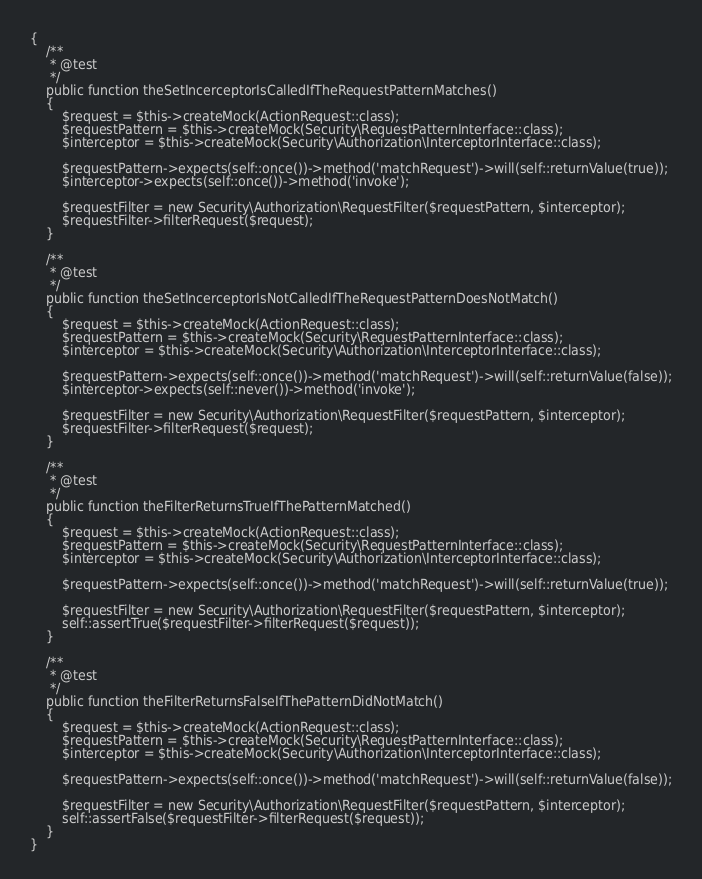<code> <loc_0><loc_0><loc_500><loc_500><_PHP_>{
    /**
     * @test
     */
    public function theSetIncerceptorIsCalledIfTheRequestPatternMatches()
    {
        $request = $this->createMock(ActionRequest::class);
        $requestPattern = $this->createMock(Security\RequestPatternInterface::class);
        $interceptor = $this->createMock(Security\Authorization\InterceptorInterface::class);

        $requestPattern->expects(self::once())->method('matchRequest')->will(self::returnValue(true));
        $interceptor->expects(self::once())->method('invoke');

        $requestFilter = new Security\Authorization\RequestFilter($requestPattern, $interceptor);
        $requestFilter->filterRequest($request);
    }

    /**
     * @test
     */
    public function theSetIncerceptorIsNotCalledIfTheRequestPatternDoesNotMatch()
    {
        $request = $this->createMock(ActionRequest::class);
        $requestPattern = $this->createMock(Security\RequestPatternInterface::class);
        $interceptor = $this->createMock(Security\Authorization\InterceptorInterface::class);

        $requestPattern->expects(self::once())->method('matchRequest')->will(self::returnValue(false));
        $interceptor->expects(self::never())->method('invoke');

        $requestFilter = new Security\Authorization\RequestFilter($requestPattern, $interceptor);
        $requestFilter->filterRequest($request);
    }

    /**
     * @test
     */
    public function theFilterReturnsTrueIfThePatternMatched()
    {
        $request = $this->createMock(ActionRequest::class);
        $requestPattern = $this->createMock(Security\RequestPatternInterface::class);
        $interceptor = $this->createMock(Security\Authorization\InterceptorInterface::class);

        $requestPattern->expects(self::once())->method('matchRequest')->will(self::returnValue(true));

        $requestFilter = new Security\Authorization\RequestFilter($requestPattern, $interceptor);
        self::assertTrue($requestFilter->filterRequest($request));
    }

    /**
     * @test
     */
    public function theFilterReturnsFalseIfThePatternDidNotMatch()
    {
        $request = $this->createMock(ActionRequest::class);
        $requestPattern = $this->createMock(Security\RequestPatternInterface::class);
        $interceptor = $this->createMock(Security\Authorization\InterceptorInterface::class);

        $requestPattern->expects(self::once())->method('matchRequest')->will(self::returnValue(false));

        $requestFilter = new Security\Authorization\RequestFilter($requestPattern, $interceptor);
        self::assertFalse($requestFilter->filterRequest($request));
    }
}
</code> 